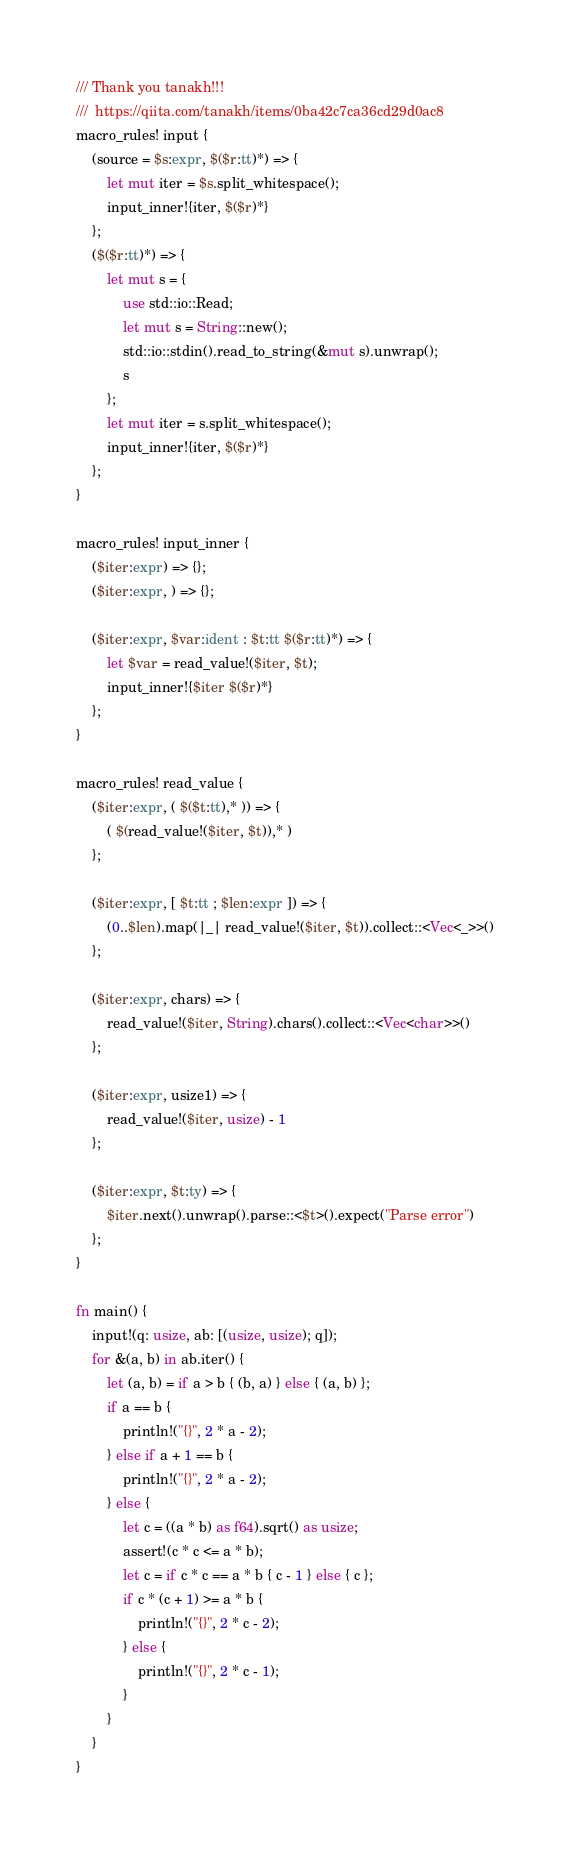Convert code to text. <code><loc_0><loc_0><loc_500><loc_500><_Rust_>/// Thank you tanakh!!!
///  https://qiita.com/tanakh/items/0ba42c7ca36cd29d0ac8
macro_rules! input {
    (source = $s:expr, $($r:tt)*) => {
        let mut iter = $s.split_whitespace();
        input_inner!{iter, $($r)*}
    };
    ($($r:tt)*) => {
        let mut s = {
            use std::io::Read;
            let mut s = String::new();
            std::io::stdin().read_to_string(&mut s).unwrap();
            s
        };
        let mut iter = s.split_whitespace();
        input_inner!{iter, $($r)*}
    };
}

macro_rules! input_inner {
    ($iter:expr) => {};
    ($iter:expr, ) => {};

    ($iter:expr, $var:ident : $t:tt $($r:tt)*) => {
        let $var = read_value!($iter, $t);
        input_inner!{$iter $($r)*}
    };
}

macro_rules! read_value {
    ($iter:expr, ( $($t:tt),* )) => {
        ( $(read_value!($iter, $t)),* )
    };

    ($iter:expr, [ $t:tt ; $len:expr ]) => {
        (0..$len).map(|_| read_value!($iter, $t)).collect::<Vec<_>>()
    };

    ($iter:expr, chars) => {
        read_value!($iter, String).chars().collect::<Vec<char>>()
    };

    ($iter:expr, usize1) => {
        read_value!($iter, usize) - 1
    };

    ($iter:expr, $t:ty) => {
        $iter.next().unwrap().parse::<$t>().expect("Parse error")
    };
}

fn main() {
    input!(q: usize, ab: [(usize, usize); q]);
    for &(a, b) in ab.iter() {
        let (a, b) = if a > b { (b, a) } else { (a, b) };
        if a == b {
            println!("{}", 2 * a - 2);
        } else if a + 1 == b {
            println!("{}", 2 * a - 2);
        } else {
            let c = ((a * b) as f64).sqrt() as usize;
            assert!(c * c <= a * b);
            let c = if c * c == a * b { c - 1 } else { c };
            if c * (c + 1) >= a * b {
                println!("{}", 2 * c - 2);
            } else {
                println!("{}", 2 * c - 1);
            }
        }
    }
}
</code> 